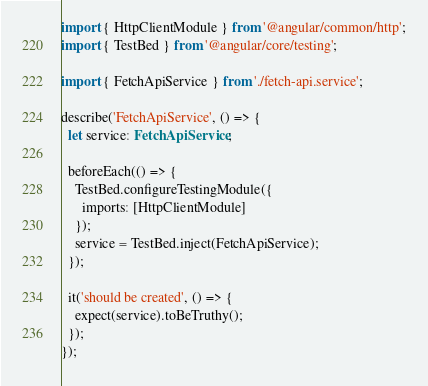<code> <loc_0><loc_0><loc_500><loc_500><_TypeScript_>import { HttpClientModule } from '@angular/common/http';
import { TestBed } from '@angular/core/testing';

import { FetchApiService } from './fetch-api.service';

describe('FetchApiService', () => {
  let service: FetchApiService;

  beforeEach(() => {
    TestBed.configureTestingModule({
      imports: [HttpClientModule]
    });
    service = TestBed.inject(FetchApiService);
  });

  it('should be created', () => {
    expect(service).toBeTruthy();
  });
});
</code> 